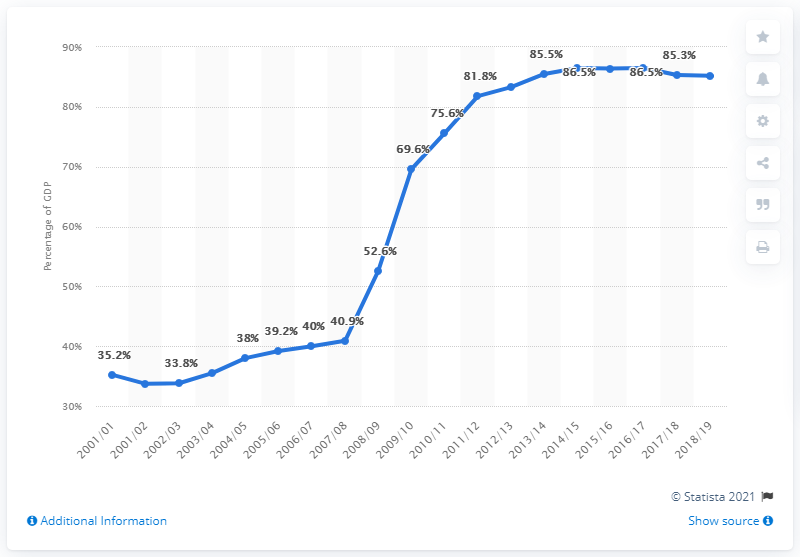Outline some significant characteristics in this image. In 2016/17, the national debt reached its peak. In 2016/17, the national debt as a percentage of GDP peaked at a level that had not been seen since 2002/03. 